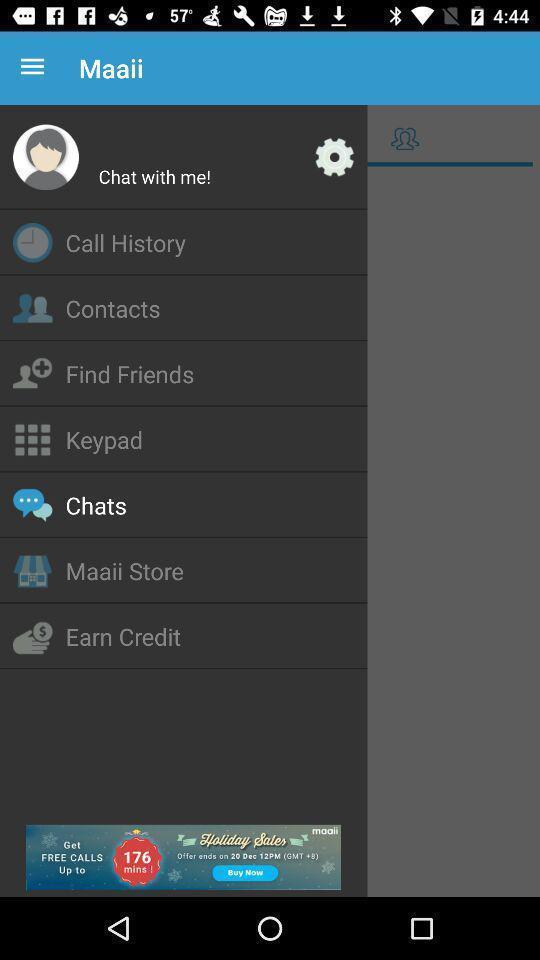What is the overall content of this screenshot? Page displaying options in social app. 